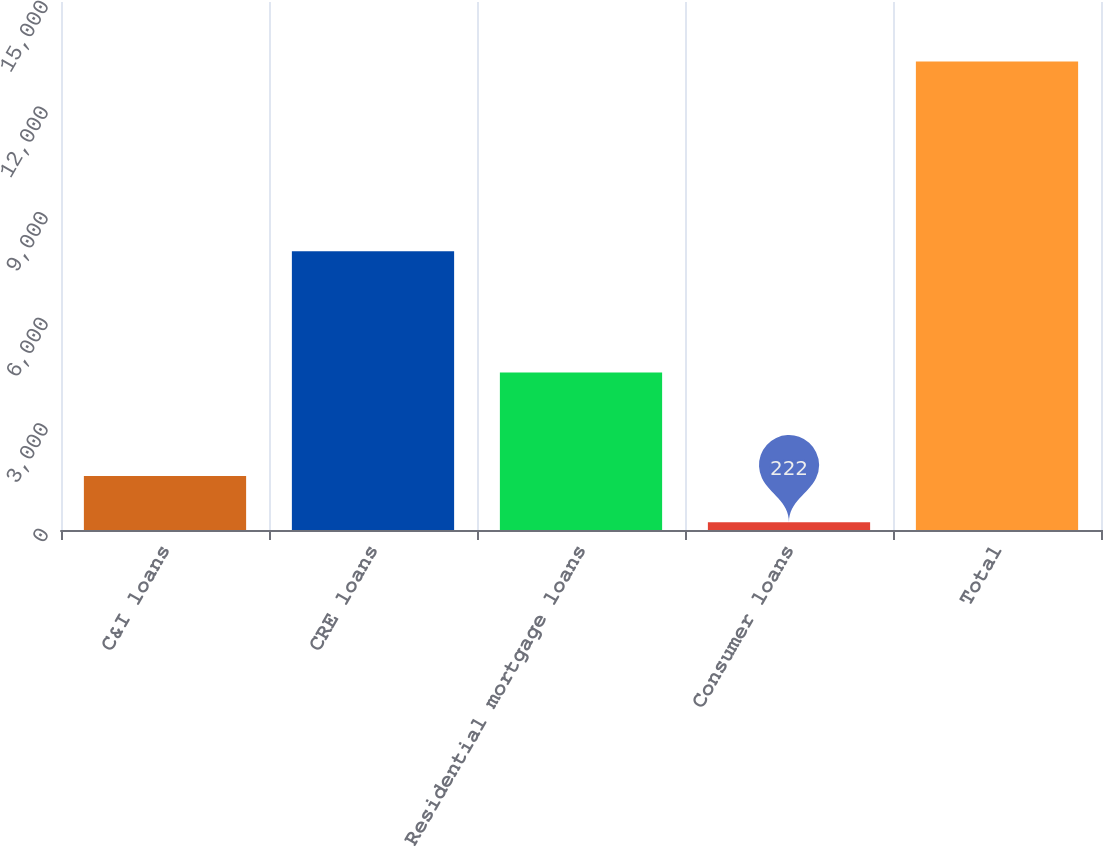Convert chart to OTSL. <chart><loc_0><loc_0><loc_500><loc_500><bar_chart><fcel>C&I loans<fcel>CRE loans<fcel>Residential mortgage loans<fcel>Consumer loans<fcel>Total<nl><fcel>1530.7<fcel>7919<fcel>4472<fcel>222<fcel>13309<nl></chart> 